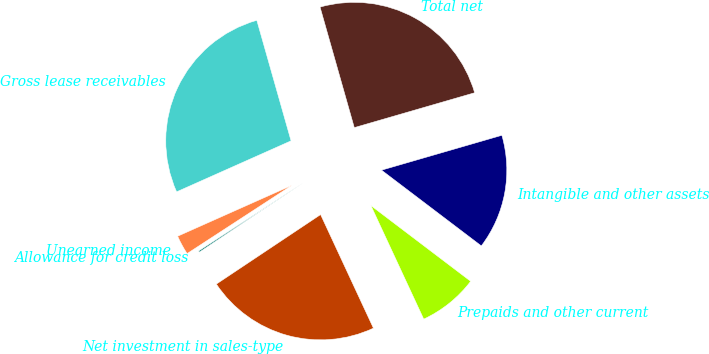<chart> <loc_0><loc_0><loc_500><loc_500><pie_chart><fcel>Gross lease receivables<fcel>Unearned income<fcel>Allowance for credit loss<fcel>Net investment in sales-type<fcel>Prepaids and other current<fcel>Intangible and other assets<fcel>Total net<nl><fcel>27.27%<fcel>2.52%<fcel>0.17%<fcel>22.57%<fcel>7.74%<fcel>14.82%<fcel>24.92%<nl></chart> 